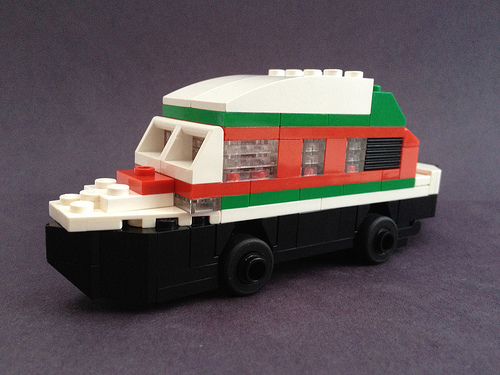<image>
Is the boat on the wheel? Yes. Looking at the image, I can see the boat is positioned on top of the wheel, with the wheel providing support. 